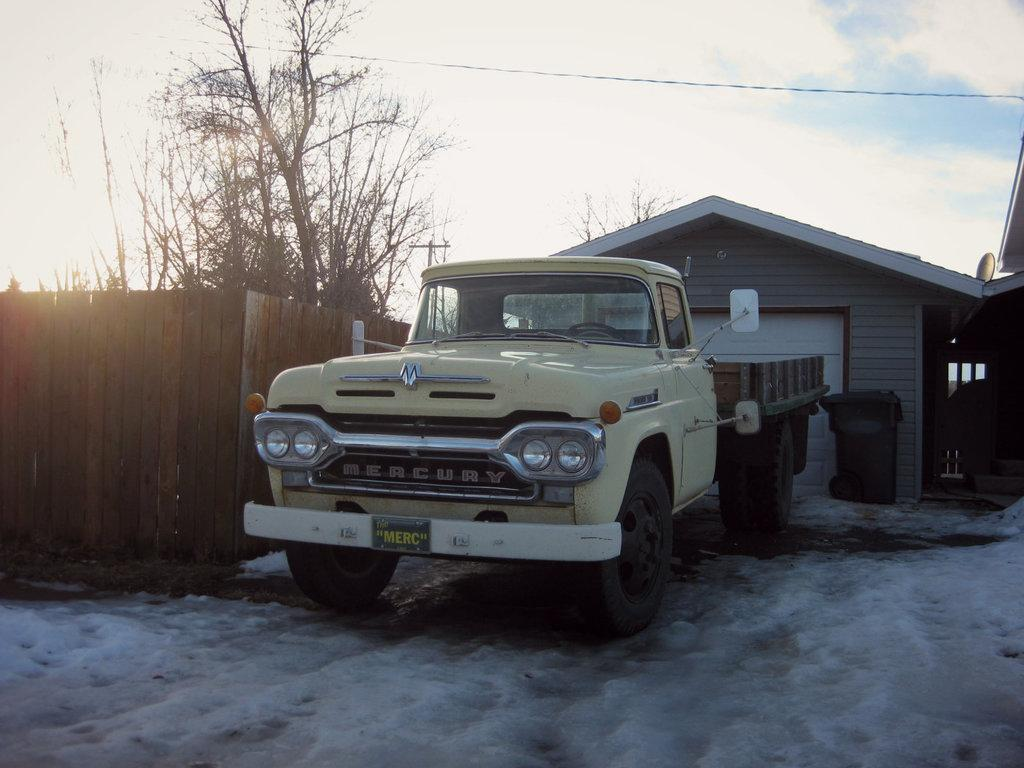<image>
Summarize the visual content of the image. an old yellow Mercury truck is sitting in front if a garage. 